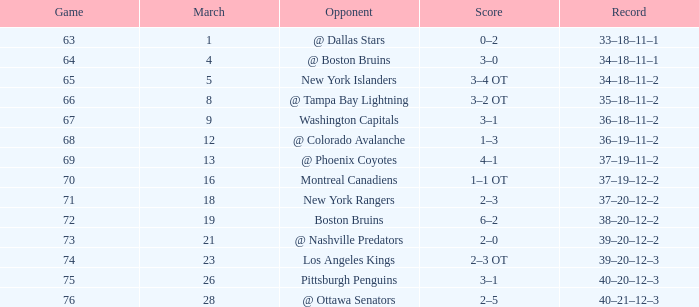How many Points have a Record of 40–21–12–3, and a March larger than 28? 0.0. 